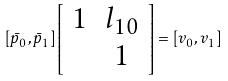Convert formula to latex. <formula><loc_0><loc_0><loc_500><loc_500>[ \bar { p } _ { 0 } , \bar { p } _ { 1 } ] \left [ \begin{array} { c c } 1 & l _ { 1 0 } \\ & 1 \end{array} \right ] = [ v _ { 0 } , v _ { 1 } ]</formula> 